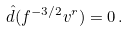<formula> <loc_0><loc_0><loc_500><loc_500>\hat { d } ( f ^ { - 3 / 2 } v ^ { r } ) = 0 \, .</formula> 